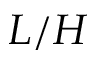<formula> <loc_0><loc_0><loc_500><loc_500>L / H</formula> 